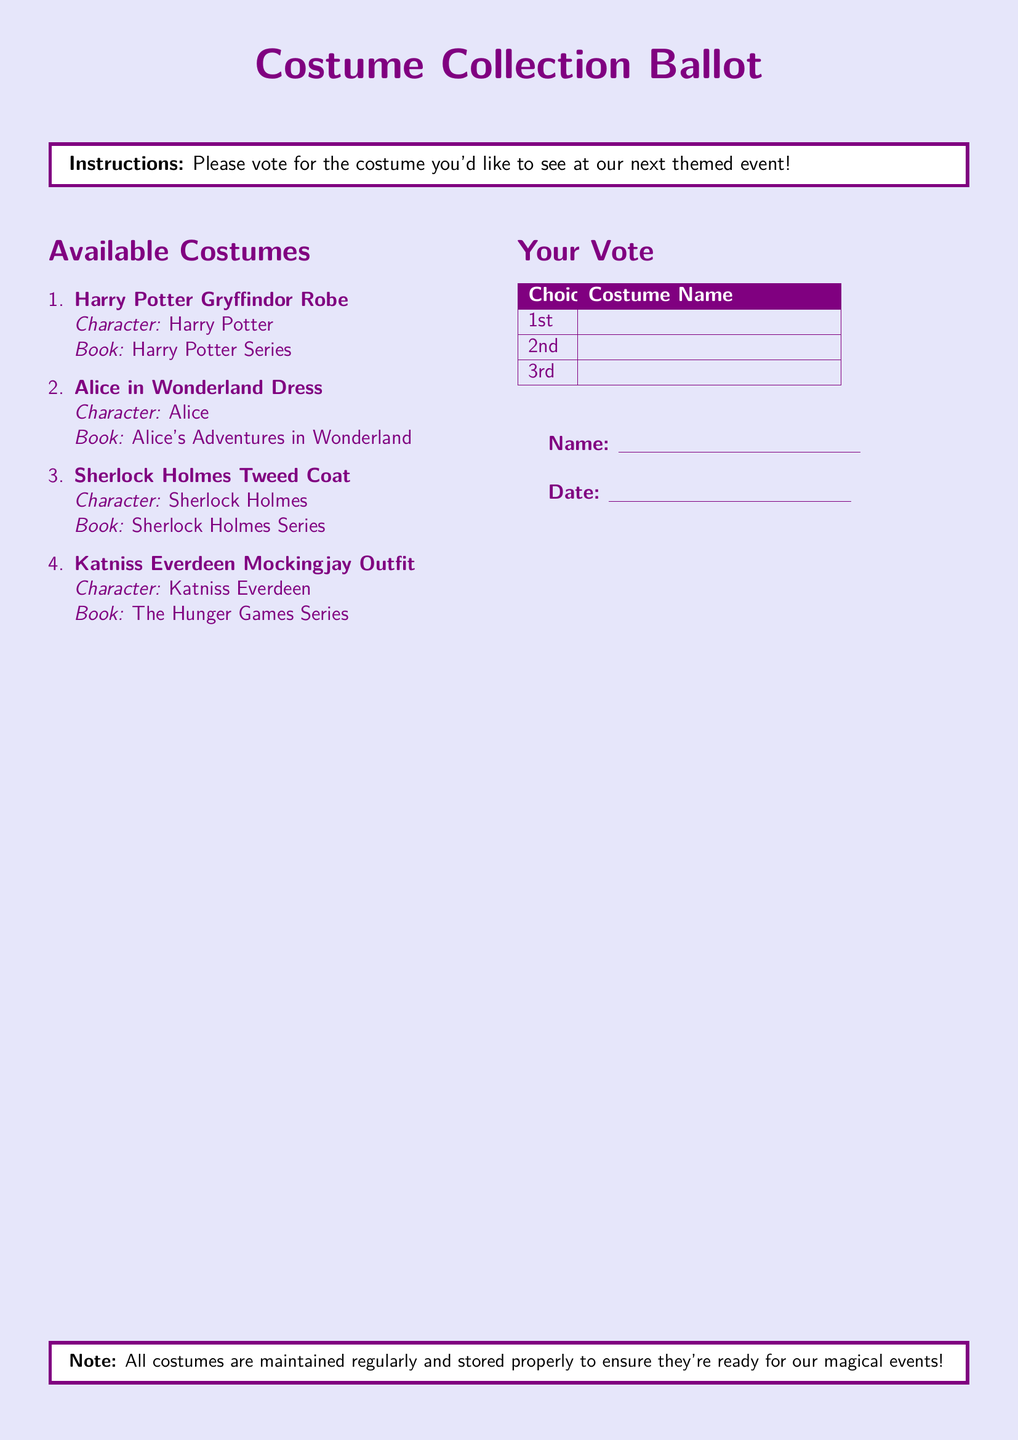what is the first available costume? The first costume listed in the document under Available Costumes is noted, which is associated with Harry Potter.
Answer: Harry Potter Gryffindor Robe who is the character associated with the second costume? The second costume is linked to Alice, as stated in the document.
Answer: Alice how many costumes are listed in total? The document mentions a total of four different costumes in the Available Costumes section.
Answer: 4 which book features the character Katniss Everdeen? The document clearly indicates that Katniss Everdeen is from The Hunger Games Series.
Answer: The Hunger Games Series what is the purpose of this ballot? The ballot's main objective is to collect votes for the costumes that participants would like to see at the next themed event.
Answer: To vote for costumes when should you fill out your name and date on the ballot? The document instructs participants to write their name and date after making their choices for the costume vote.
Answer: After voting what is the note at the bottom of the document about? The note informs participants that all costumes are maintained and stored properly for upcoming events.
Answer: Maintenance and storage of costumes what color is used for the background of the document? The background color utilized in the document is light purple, as defined at the beginning.
Answer: Light purple 